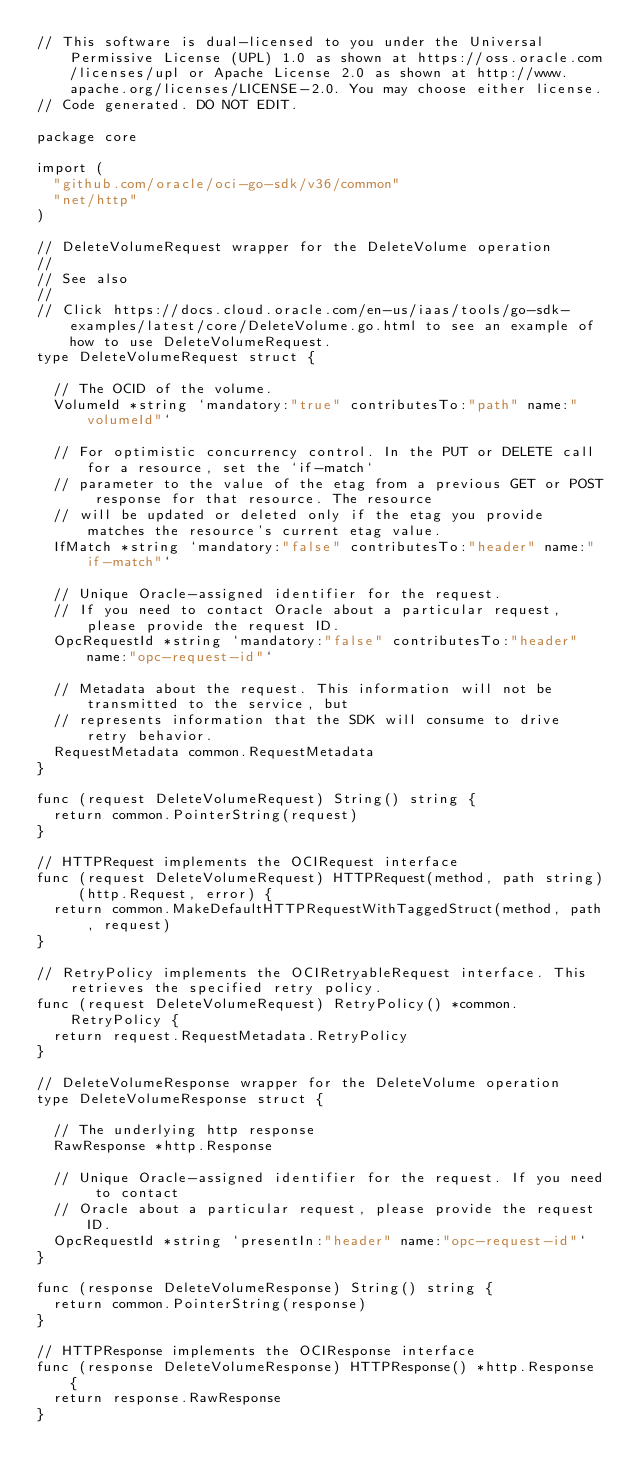<code> <loc_0><loc_0><loc_500><loc_500><_Go_>// This software is dual-licensed to you under the Universal Permissive License (UPL) 1.0 as shown at https://oss.oracle.com/licenses/upl or Apache License 2.0 as shown at http://www.apache.org/licenses/LICENSE-2.0. You may choose either license.
// Code generated. DO NOT EDIT.

package core

import (
	"github.com/oracle/oci-go-sdk/v36/common"
	"net/http"
)

// DeleteVolumeRequest wrapper for the DeleteVolume operation
//
// See also
//
// Click https://docs.cloud.oracle.com/en-us/iaas/tools/go-sdk-examples/latest/core/DeleteVolume.go.html to see an example of how to use DeleteVolumeRequest.
type DeleteVolumeRequest struct {

	// The OCID of the volume.
	VolumeId *string `mandatory:"true" contributesTo:"path" name:"volumeId"`

	// For optimistic concurrency control. In the PUT or DELETE call for a resource, set the `if-match`
	// parameter to the value of the etag from a previous GET or POST response for that resource. The resource
	// will be updated or deleted only if the etag you provide matches the resource's current etag value.
	IfMatch *string `mandatory:"false" contributesTo:"header" name:"if-match"`

	// Unique Oracle-assigned identifier for the request.
	// If you need to contact Oracle about a particular request, please provide the request ID.
	OpcRequestId *string `mandatory:"false" contributesTo:"header" name:"opc-request-id"`

	// Metadata about the request. This information will not be transmitted to the service, but
	// represents information that the SDK will consume to drive retry behavior.
	RequestMetadata common.RequestMetadata
}

func (request DeleteVolumeRequest) String() string {
	return common.PointerString(request)
}

// HTTPRequest implements the OCIRequest interface
func (request DeleteVolumeRequest) HTTPRequest(method, path string) (http.Request, error) {
	return common.MakeDefaultHTTPRequestWithTaggedStruct(method, path, request)
}

// RetryPolicy implements the OCIRetryableRequest interface. This retrieves the specified retry policy.
func (request DeleteVolumeRequest) RetryPolicy() *common.RetryPolicy {
	return request.RequestMetadata.RetryPolicy
}

// DeleteVolumeResponse wrapper for the DeleteVolume operation
type DeleteVolumeResponse struct {

	// The underlying http response
	RawResponse *http.Response

	// Unique Oracle-assigned identifier for the request. If you need to contact
	// Oracle about a particular request, please provide the request ID.
	OpcRequestId *string `presentIn:"header" name:"opc-request-id"`
}

func (response DeleteVolumeResponse) String() string {
	return common.PointerString(response)
}

// HTTPResponse implements the OCIResponse interface
func (response DeleteVolumeResponse) HTTPResponse() *http.Response {
	return response.RawResponse
}
</code> 